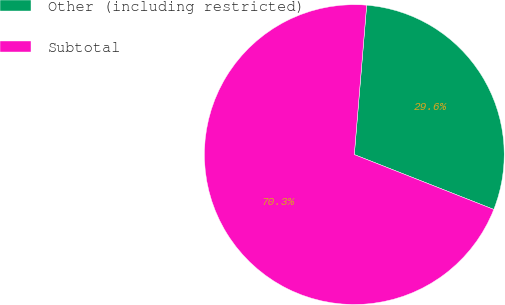Convert chart to OTSL. <chart><loc_0><loc_0><loc_500><loc_500><pie_chart><fcel>Other (including restricted)<fcel>Subtotal<nl><fcel>29.65%<fcel>70.35%<nl></chart> 